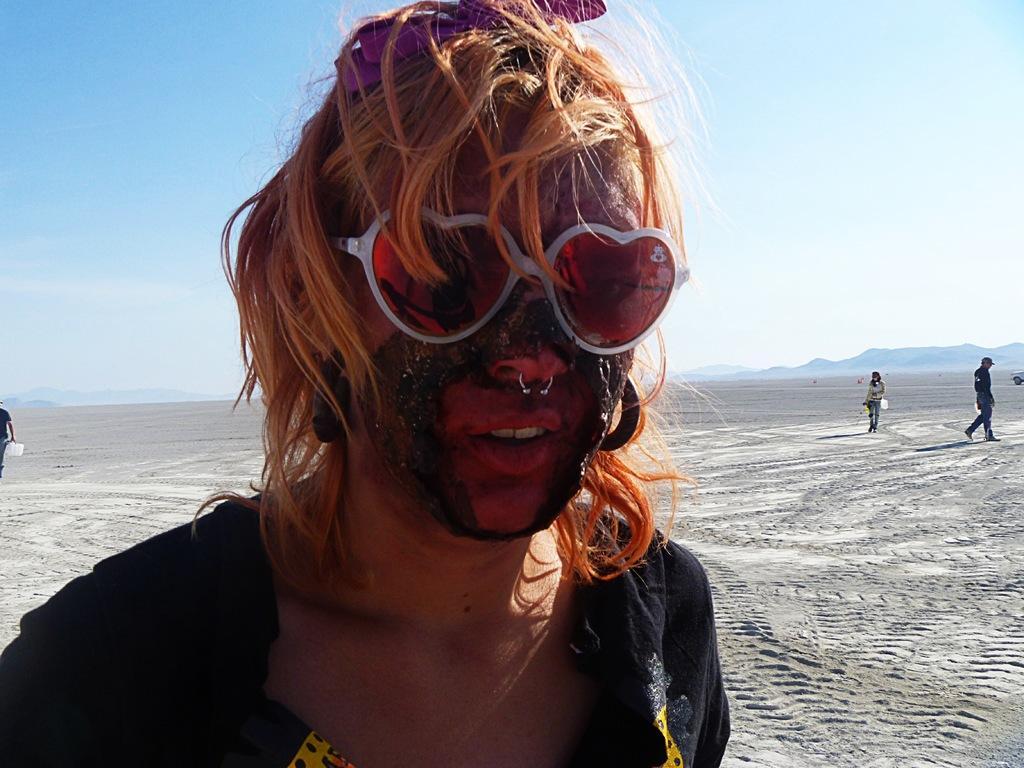Can you describe this image briefly? In this image there is a person standing on the ground. The person is wearing spectacles. Behind the person there are a few people walking on the ground. In the background there are mountains. At the top there is the sky. 